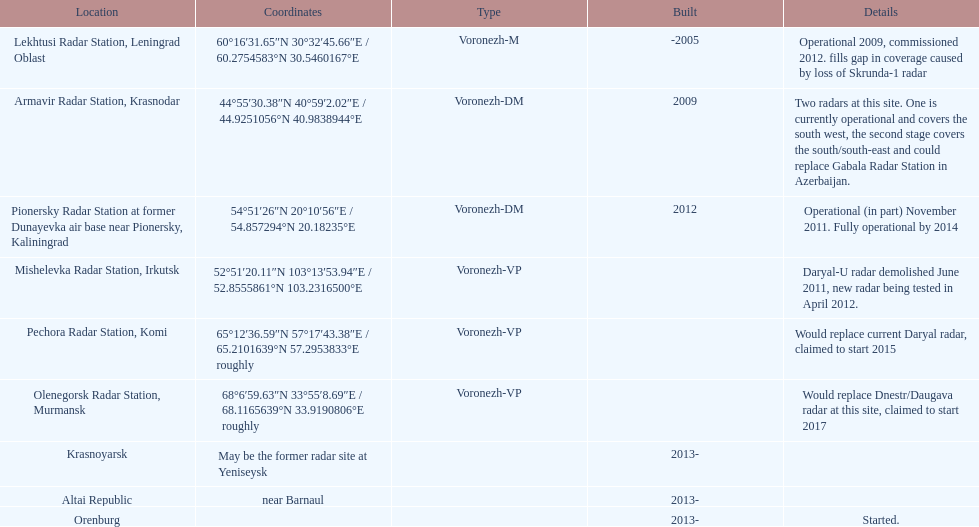66"e / 6 Lekhtusi Radar Station, Leningrad Oblast. Can you give me this table as a dict? {'header': ['Location', 'Coordinates', 'Type', 'Built', 'Details'], 'rows': [['Lekhtusi Radar Station, Leningrad Oblast', '60°16′31.65″N 30°32′45.66″E\ufeff / \ufeff60.2754583°N 30.5460167°E', 'Voronezh-M', '-2005', 'Operational 2009, commissioned 2012. fills gap in coverage caused by loss of Skrunda-1 radar'], ['Armavir Radar Station, Krasnodar', '44°55′30.38″N 40°59′2.02″E\ufeff / \ufeff44.9251056°N 40.9838944°E', 'Voronezh-DM', '2009', 'Two radars at this site. One is currently operational and covers the south west, the second stage covers the south/south-east and could replace Gabala Radar Station in Azerbaijan.'], ['Pionersky Radar Station at former Dunayevka air base near Pionersky, Kaliningrad', '54°51′26″N 20°10′56″E\ufeff / \ufeff54.857294°N 20.18235°E', 'Voronezh-DM', '2012', 'Operational (in part) November 2011. Fully operational by 2014'], ['Mishelevka Radar Station, Irkutsk', '52°51′20.11″N 103°13′53.94″E\ufeff / \ufeff52.8555861°N 103.2316500°E', 'Voronezh-VP', '', 'Daryal-U radar demolished June 2011, new radar being tested in April 2012.'], ['Pechora Radar Station, Komi', '65°12′36.59″N 57°17′43.38″E\ufeff / \ufeff65.2101639°N 57.2953833°E roughly', 'Voronezh-VP', '', 'Would replace current Daryal radar, claimed to start 2015'], ['Olenegorsk Radar Station, Murmansk', '68°6′59.63″N 33°55′8.69″E\ufeff / \ufeff68.1165639°N 33.9190806°E roughly', 'Voronezh-VP', '', 'Would replace Dnestr/Daugava radar at this site, claimed to start 2017'], ['Krasnoyarsk', 'May be the former radar site at Yeniseysk', '', '2013-', ''], ['Altai Republic', 'near Barnaul', '', '2013-', ''], ['Orenburg', '', '', '2013-', 'Started.']]} 